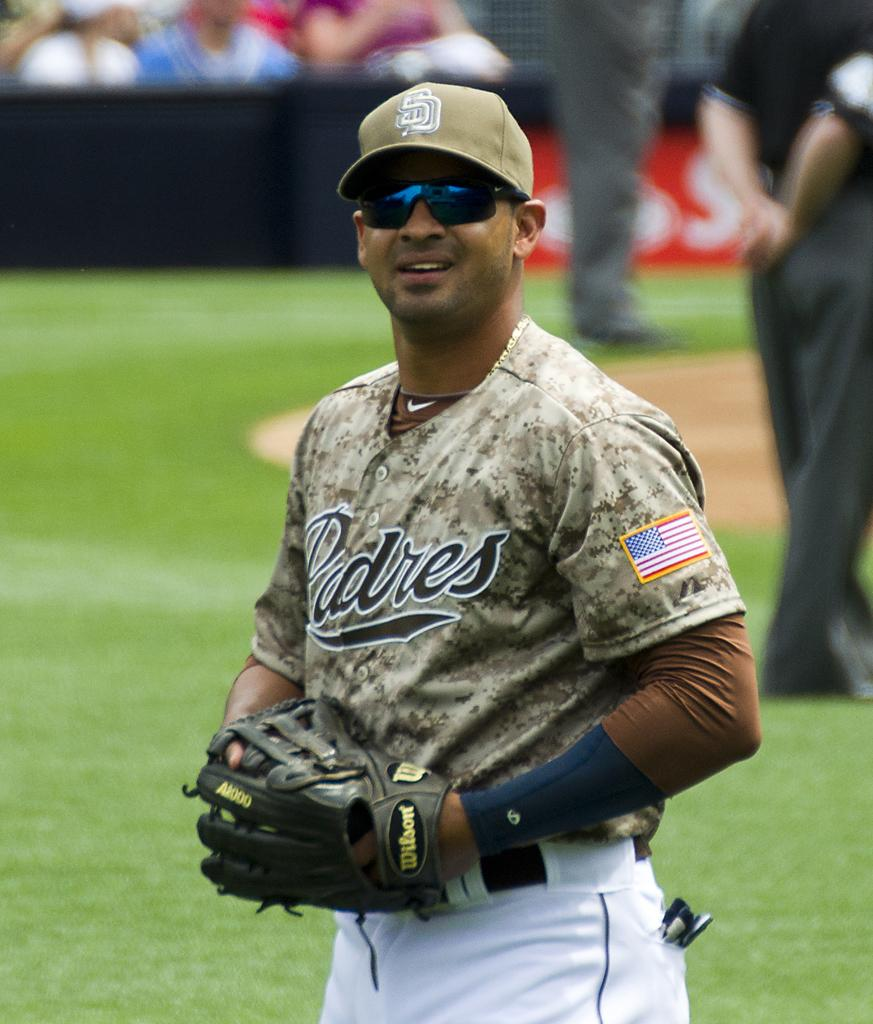<image>
Write a terse but informative summary of the picture. A man in a camo Padres uniform stands on a baseball field. 